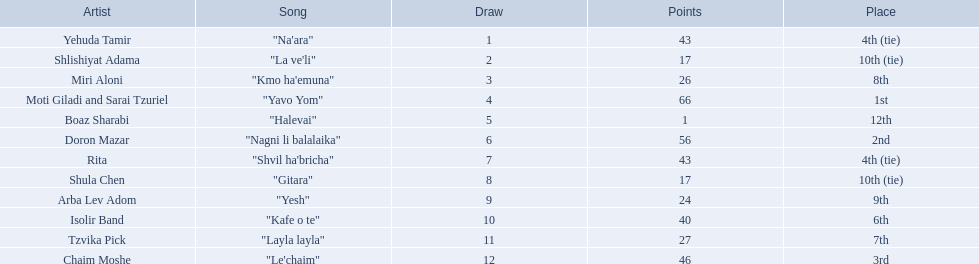Who are all of the artists? Yehuda Tamir, Shlishiyat Adama, Miri Aloni, Moti Giladi and Sarai Tzuriel, Boaz Sharabi, Doron Mazar, Rita, Shula Chen, Arba Lev Adom, Isolir Band, Tzvika Pick, Chaim Moshe. How many points did each score? 43, 17, 26, 66, 1, 56, 43, 17, 24, 40, 27, 46. And which artist had the least amount of points? Boaz Sharabi. 